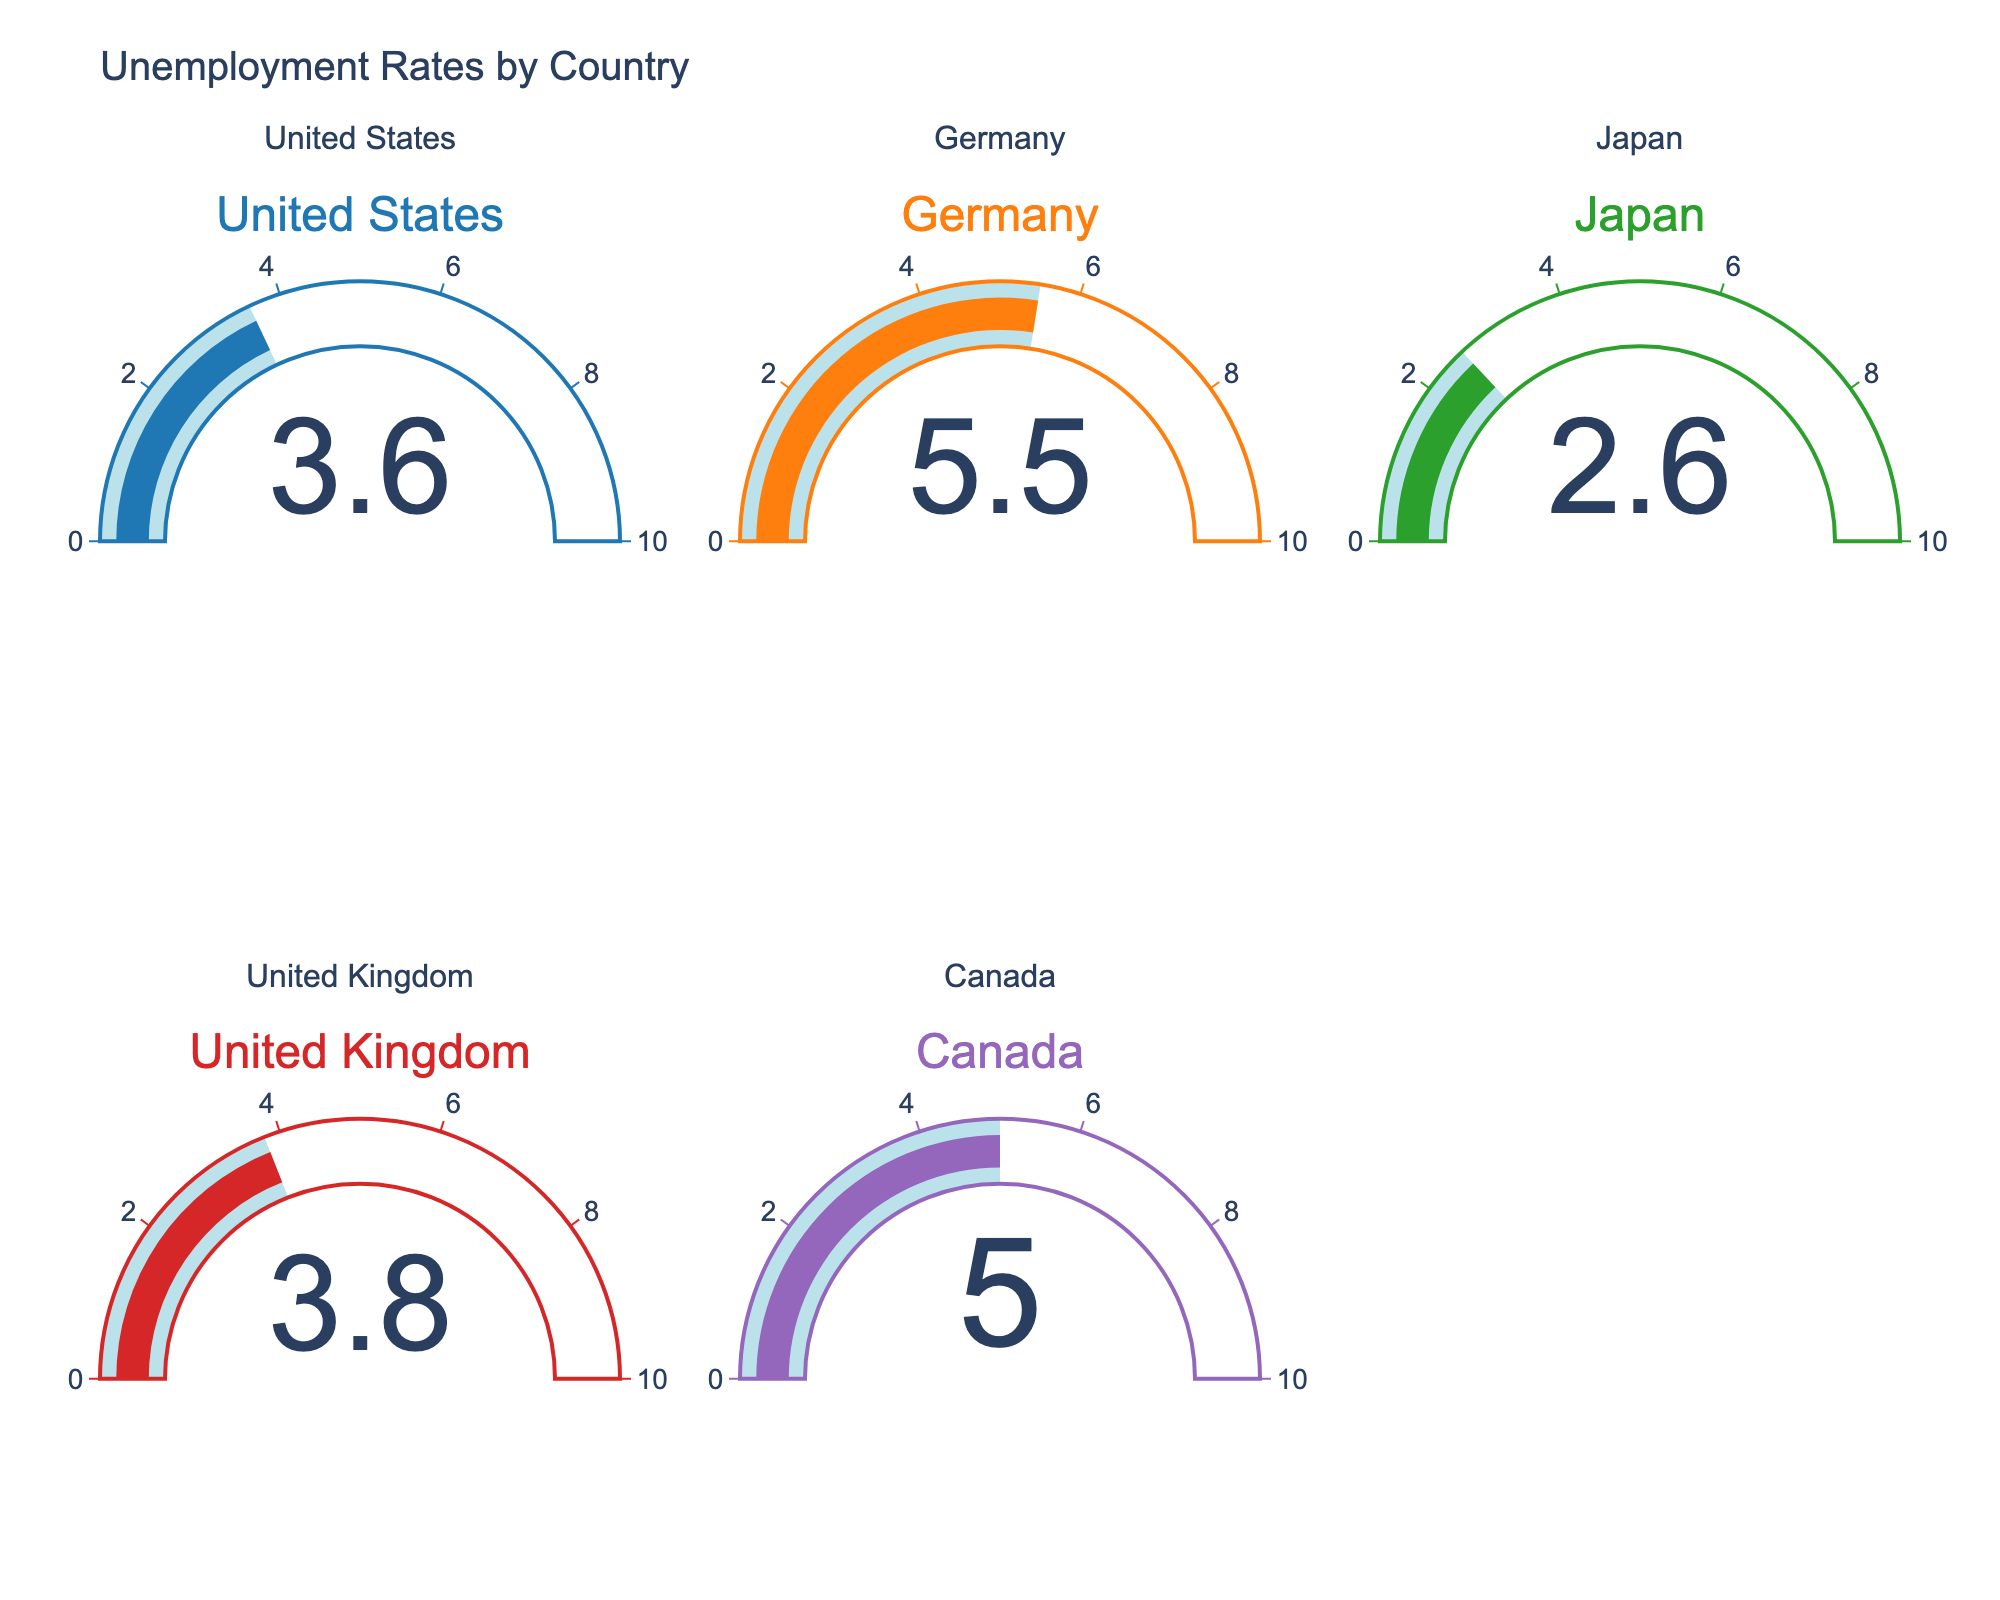What is the title of the chart? The title is typically located at the top center of the chart. In this case, it says "Unemployment Rates by Country".
Answer: Unemployment Rates by Country How many countries are presented in the chart? By counting the number of gauges, there are five countries shown in the chart.
Answer: 5 Which country has the lowest unemployment rate? By observing the value on each gauge, Japan has the lowest rate at 2.6%.
Answer: Japan Which country has the highest unemployment rate? By comparing the values on each gauge, Germany has the highest rate at 5.5%.
Answer: Germany What is the total sum of the unemployment rates presented? Adding each unemployment rate: 3.6 (United States) + 5.5 (Germany) + 2.6 (Japan) + 3.8 (United Kingdom) + 5.0 (Canada) results in a sum of 20.5.
Answer: 20.5 What is the average unemployment rate across these countries? Adding each unemployment rate: 3.6 (United States) + 5.5 (Germany) + 2.6 (Japan) + 3.8 (United Kingdom) + 5.0 (Canada) gives a total of 20.5. Dividing by the number of countries (5), the average rate is 20.5 / 5 = 4.1%.
Answer: 4.1% Which countries have unemployment rates below the average rate? The average unemployment rate is 4.1%. Comparing each country, the United States (3.6), Japan (2.6), and the United Kingdom (3.8) are below this average.
Answer: United States, Japan, United Kingdom How much higher is Germany's unemployment rate compared to Japan's? Subtracting Japan's rate (2.6%) from Germany's rate (5.5%): 5.5 - 2.6 = 2.9%.
Answer: 2.9% 